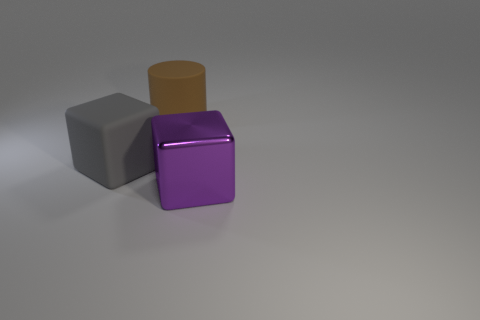The gray block that is made of the same material as the big brown object is what size?
Keep it short and to the point. Large. There is a thing behind the object that is on the left side of the big matte thing right of the gray cube; what is its size?
Keep it short and to the point. Large. There is a block that is right of the big cylinder; how big is it?
Offer a terse response. Large. What number of purple things are either large matte cylinders or large blocks?
Make the answer very short. 1. Are there any purple cubes that have the same size as the metal object?
Make the answer very short. No. What is the material of the cylinder that is the same size as the metal object?
Your answer should be compact. Rubber. There is a matte thing in front of the big brown object; does it have the same size as the thing on the right side of the brown matte object?
Your answer should be very brief. Yes. How many things are either small red metallic cylinders or things that are behind the gray thing?
Provide a short and direct response. 1. Are there any tiny gray matte objects of the same shape as the large metal thing?
Ensure brevity in your answer.  No. How big is the cube in front of the large block left of the large purple metal thing?
Provide a short and direct response. Large. 